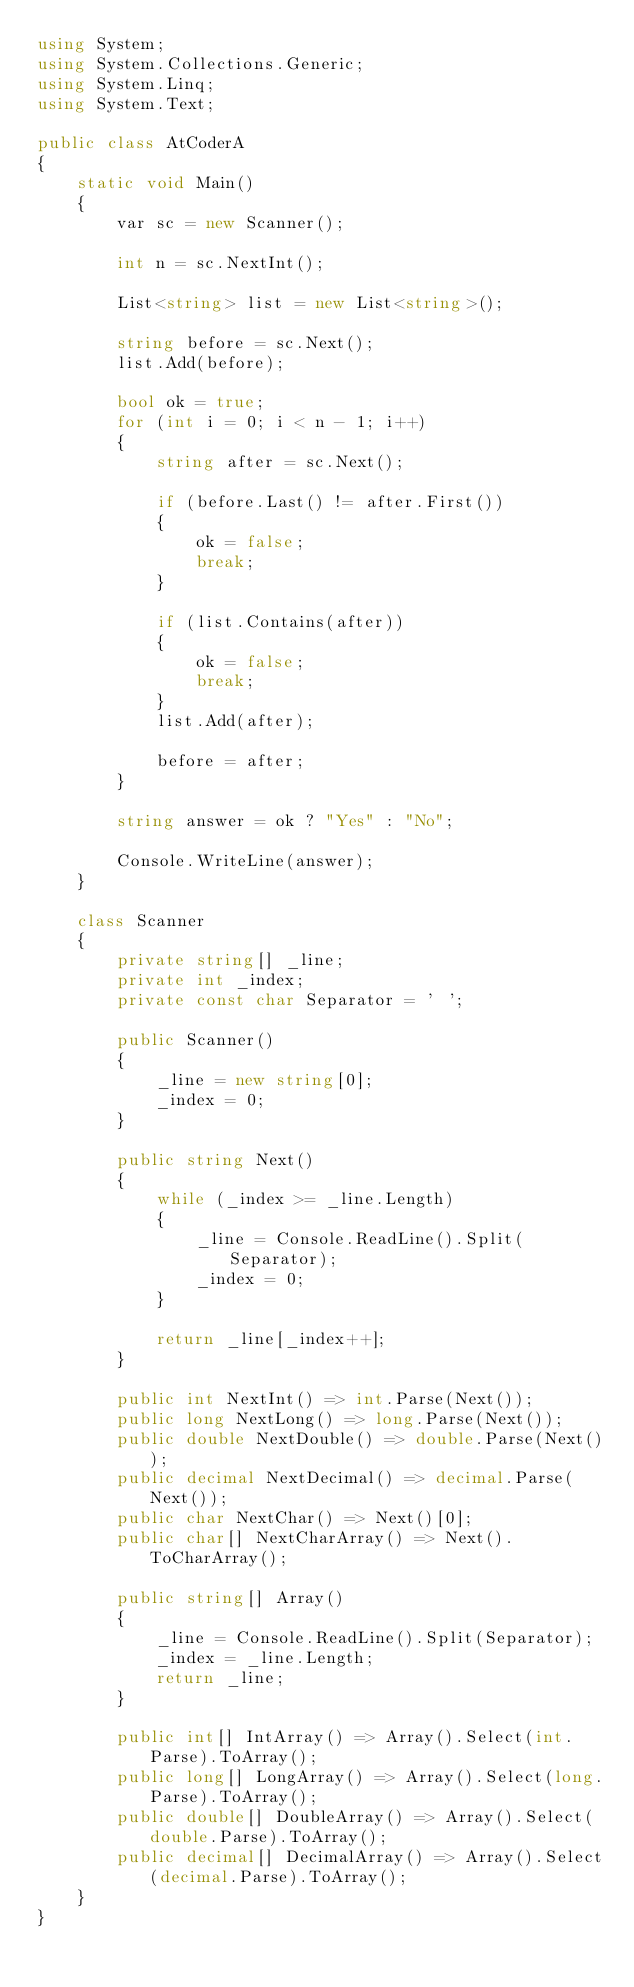<code> <loc_0><loc_0><loc_500><loc_500><_C#_>using System;
using System.Collections.Generic;
using System.Linq;
using System.Text;

public class AtCoderA
{
    static void Main()
    {
        var sc = new Scanner();

        int n = sc.NextInt();

        List<string> list = new List<string>();

        string before = sc.Next();
        list.Add(before);

        bool ok = true;
        for (int i = 0; i < n - 1; i++)
        {
            string after = sc.Next();

            if (before.Last() != after.First())
            {
                ok = false;
                break;
            }

            if (list.Contains(after))
            {
                ok = false;
                break;
            }
            list.Add(after);

            before = after;
        }

        string answer = ok ? "Yes" : "No";

        Console.WriteLine(answer);
    }

    class Scanner
    {
        private string[] _line;
        private int _index;
        private const char Separator = ' ';

        public Scanner()
        {
            _line = new string[0];
            _index = 0;
        }

        public string Next()
        {
            while (_index >= _line.Length)
            {
                _line = Console.ReadLine().Split(Separator);
                _index = 0;
            }

            return _line[_index++];
        }

        public int NextInt() => int.Parse(Next());
        public long NextLong() => long.Parse(Next());
        public double NextDouble() => double.Parse(Next());
        public decimal NextDecimal() => decimal.Parse(Next());
        public char NextChar() => Next()[0];
        public char[] NextCharArray() => Next().ToCharArray();

        public string[] Array()
        {
            _line = Console.ReadLine().Split(Separator);
            _index = _line.Length;
            return _line;
        }

        public int[] IntArray() => Array().Select(int.Parse).ToArray();
        public long[] LongArray() => Array().Select(long.Parse).ToArray();
        public double[] DoubleArray() => Array().Select(double.Parse).ToArray();
        public decimal[] DecimalArray() => Array().Select(decimal.Parse).ToArray();
    }
}</code> 